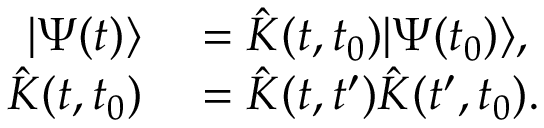<formula> <loc_0><loc_0><loc_500><loc_500>\begin{array} { r l } { | \Psi ( t ) \rangle } & = \hat { K } ( t , t _ { 0 } ) | \Psi ( t _ { 0 } ) \rangle , } \\ { \hat { K } ( t , t _ { 0 } ) } & = \hat { K } ( t , t ^ { \prime } ) \hat { K } ( t ^ { \prime } , t _ { 0 } ) . } \end{array}</formula> 